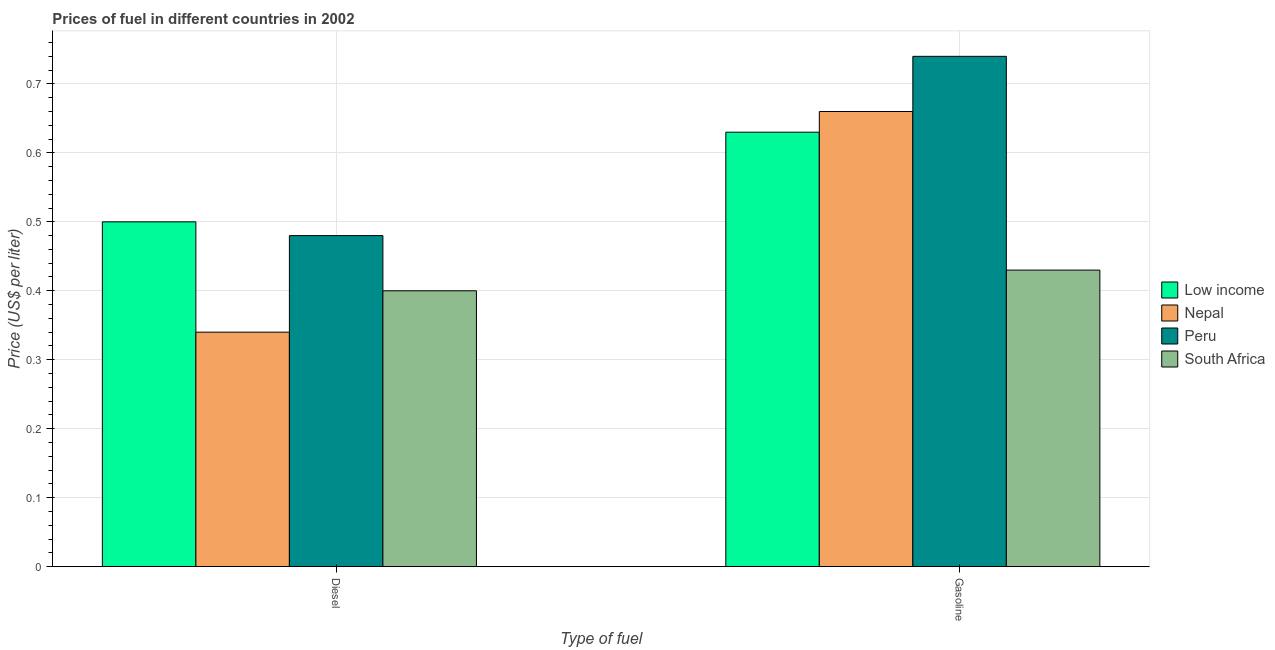How many different coloured bars are there?
Your answer should be compact. 4. Are the number of bars on each tick of the X-axis equal?
Offer a terse response. Yes. How many bars are there on the 2nd tick from the left?
Offer a terse response. 4. How many bars are there on the 2nd tick from the right?
Give a very brief answer. 4. What is the label of the 2nd group of bars from the left?
Provide a succinct answer. Gasoline. Across all countries, what is the maximum gasoline price?
Give a very brief answer. 0.74. Across all countries, what is the minimum gasoline price?
Provide a short and direct response. 0.43. In which country was the diesel price maximum?
Your answer should be very brief. Low income. In which country was the gasoline price minimum?
Give a very brief answer. South Africa. What is the total diesel price in the graph?
Your response must be concise. 1.72. What is the difference between the diesel price in Low income and that in South Africa?
Provide a succinct answer. 0.1. What is the difference between the diesel price in Nepal and the gasoline price in Peru?
Your answer should be compact. -0.4. What is the average gasoline price per country?
Your response must be concise. 0.62. What is the difference between the gasoline price and diesel price in Peru?
Offer a terse response. 0.26. What is the ratio of the diesel price in Peru to that in Low income?
Provide a succinct answer. 0.96. In how many countries, is the diesel price greater than the average diesel price taken over all countries?
Provide a succinct answer. 2. What does the 3rd bar from the right in Diesel represents?
Your answer should be compact. Nepal. How many bars are there?
Give a very brief answer. 8. What is the difference between two consecutive major ticks on the Y-axis?
Offer a very short reply. 0.1. Does the graph contain any zero values?
Your response must be concise. No. What is the title of the graph?
Offer a very short reply. Prices of fuel in different countries in 2002. What is the label or title of the X-axis?
Your answer should be compact. Type of fuel. What is the label or title of the Y-axis?
Ensure brevity in your answer.  Price (US$ per liter). What is the Price (US$ per liter) in Nepal in Diesel?
Your answer should be very brief. 0.34. What is the Price (US$ per liter) of Peru in Diesel?
Ensure brevity in your answer.  0.48. What is the Price (US$ per liter) of Low income in Gasoline?
Provide a short and direct response. 0.63. What is the Price (US$ per liter) of Nepal in Gasoline?
Your answer should be compact. 0.66. What is the Price (US$ per liter) of Peru in Gasoline?
Make the answer very short. 0.74. What is the Price (US$ per liter) of South Africa in Gasoline?
Your answer should be very brief. 0.43. Across all Type of fuel, what is the maximum Price (US$ per liter) of Low income?
Provide a succinct answer. 0.63. Across all Type of fuel, what is the maximum Price (US$ per liter) of Nepal?
Make the answer very short. 0.66. Across all Type of fuel, what is the maximum Price (US$ per liter) of Peru?
Your answer should be compact. 0.74. Across all Type of fuel, what is the maximum Price (US$ per liter) in South Africa?
Your answer should be very brief. 0.43. Across all Type of fuel, what is the minimum Price (US$ per liter) of Nepal?
Ensure brevity in your answer.  0.34. Across all Type of fuel, what is the minimum Price (US$ per liter) in Peru?
Your answer should be compact. 0.48. What is the total Price (US$ per liter) in Low income in the graph?
Make the answer very short. 1.13. What is the total Price (US$ per liter) in Nepal in the graph?
Keep it short and to the point. 1. What is the total Price (US$ per liter) of Peru in the graph?
Your answer should be very brief. 1.22. What is the total Price (US$ per liter) in South Africa in the graph?
Offer a terse response. 0.83. What is the difference between the Price (US$ per liter) of Low income in Diesel and that in Gasoline?
Ensure brevity in your answer.  -0.13. What is the difference between the Price (US$ per liter) of Nepal in Diesel and that in Gasoline?
Your answer should be compact. -0.32. What is the difference between the Price (US$ per liter) in Peru in Diesel and that in Gasoline?
Offer a terse response. -0.26. What is the difference between the Price (US$ per liter) in South Africa in Diesel and that in Gasoline?
Keep it short and to the point. -0.03. What is the difference between the Price (US$ per liter) of Low income in Diesel and the Price (US$ per liter) of Nepal in Gasoline?
Provide a short and direct response. -0.16. What is the difference between the Price (US$ per liter) of Low income in Diesel and the Price (US$ per liter) of Peru in Gasoline?
Offer a very short reply. -0.24. What is the difference between the Price (US$ per liter) in Low income in Diesel and the Price (US$ per liter) in South Africa in Gasoline?
Give a very brief answer. 0.07. What is the difference between the Price (US$ per liter) of Nepal in Diesel and the Price (US$ per liter) of Peru in Gasoline?
Offer a terse response. -0.4. What is the difference between the Price (US$ per liter) in Nepal in Diesel and the Price (US$ per liter) in South Africa in Gasoline?
Your answer should be compact. -0.09. What is the difference between the Price (US$ per liter) in Peru in Diesel and the Price (US$ per liter) in South Africa in Gasoline?
Offer a very short reply. 0.05. What is the average Price (US$ per liter) of Low income per Type of fuel?
Your response must be concise. 0.56. What is the average Price (US$ per liter) of Nepal per Type of fuel?
Make the answer very short. 0.5. What is the average Price (US$ per liter) in Peru per Type of fuel?
Your answer should be very brief. 0.61. What is the average Price (US$ per liter) in South Africa per Type of fuel?
Keep it short and to the point. 0.41. What is the difference between the Price (US$ per liter) in Low income and Price (US$ per liter) in Nepal in Diesel?
Your response must be concise. 0.16. What is the difference between the Price (US$ per liter) in Low income and Price (US$ per liter) in South Africa in Diesel?
Ensure brevity in your answer.  0.1. What is the difference between the Price (US$ per liter) in Nepal and Price (US$ per liter) in Peru in Diesel?
Give a very brief answer. -0.14. What is the difference between the Price (US$ per liter) in Nepal and Price (US$ per liter) in South Africa in Diesel?
Give a very brief answer. -0.06. What is the difference between the Price (US$ per liter) of Peru and Price (US$ per liter) of South Africa in Diesel?
Keep it short and to the point. 0.08. What is the difference between the Price (US$ per liter) in Low income and Price (US$ per liter) in Nepal in Gasoline?
Offer a very short reply. -0.03. What is the difference between the Price (US$ per liter) of Low income and Price (US$ per liter) of Peru in Gasoline?
Make the answer very short. -0.11. What is the difference between the Price (US$ per liter) in Low income and Price (US$ per liter) in South Africa in Gasoline?
Give a very brief answer. 0.2. What is the difference between the Price (US$ per liter) in Nepal and Price (US$ per liter) in Peru in Gasoline?
Offer a terse response. -0.08. What is the difference between the Price (US$ per liter) in Nepal and Price (US$ per liter) in South Africa in Gasoline?
Your response must be concise. 0.23. What is the difference between the Price (US$ per liter) in Peru and Price (US$ per liter) in South Africa in Gasoline?
Give a very brief answer. 0.31. What is the ratio of the Price (US$ per liter) in Low income in Diesel to that in Gasoline?
Provide a short and direct response. 0.79. What is the ratio of the Price (US$ per liter) in Nepal in Diesel to that in Gasoline?
Your answer should be compact. 0.52. What is the ratio of the Price (US$ per liter) in Peru in Diesel to that in Gasoline?
Offer a terse response. 0.65. What is the ratio of the Price (US$ per liter) of South Africa in Diesel to that in Gasoline?
Provide a short and direct response. 0.93. What is the difference between the highest and the second highest Price (US$ per liter) of Low income?
Give a very brief answer. 0.13. What is the difference between the highest and the second highest Price (US$ per liter) of Nepal?
Offer a terse response. 0.32. What is the difference between the highest and the second highest Price (US$ per liter) of Peru?
Offer a very short reply. 0.26. What is the difference between the highest and the second highest Price (US$ per liter) in South Africa?
Keep it short and to the point. 0.03. What is the difference between the highest and the lowest Price (US$ per liter) in Low income?
Your answer should be compact. 0.13. What is the difference between the highest and the lowest Price (US$ per liter) of Nepal?
Your answer should be very brief. 0.32. What is the difference between the highest and the lowest Price (US$ per liter) of Peru?
Keep it short and to the point. 0.26. What is the difference between the highest and the lowest Price (US$ per liter) in South Africa?
Your answer should be very brief. 0.03. 